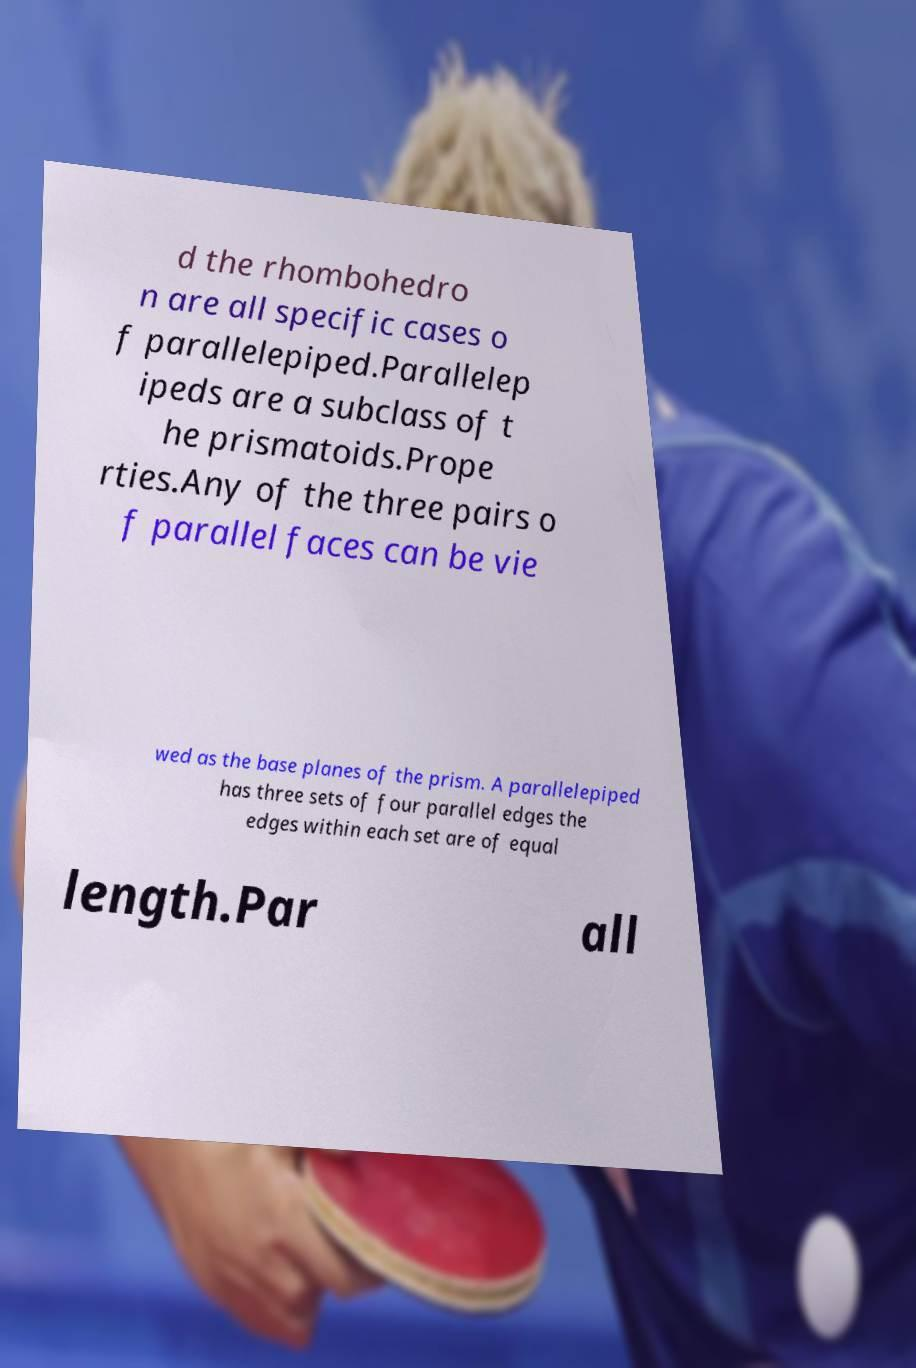Can you accurately transcribe the text from the provided image for me? d the rhombohedro n are all specific cases o f parallelepiped.Parallelep ipeds are a subclass of t he prismatoids.Prope rties.Any of the three pairs o f parallel faces can be vie wed as the base planes of the prism. A parallelepiped has three sets of four parallel edges the edges within each set are of equal length.Par all 